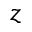<formula> <loc_0><loc_0><loc_500><loc_500>z</formula> 